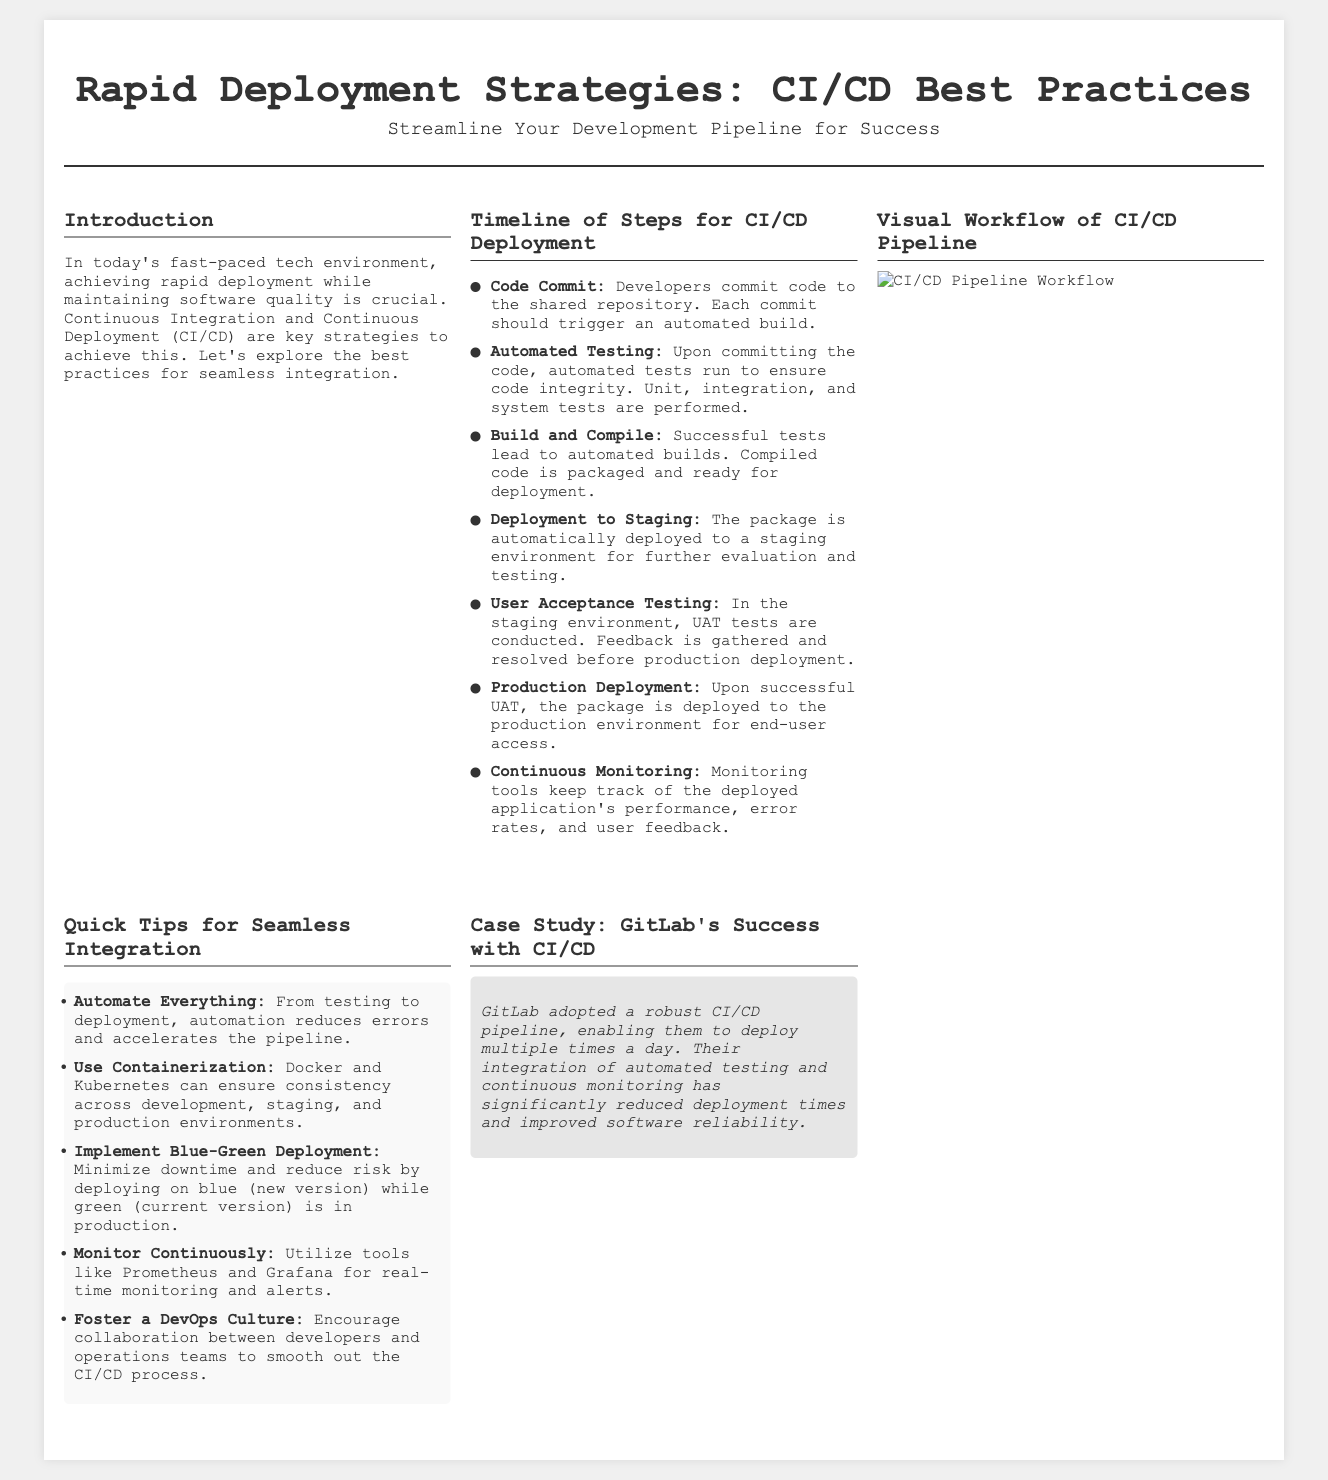What is the main title of the document? The title is prominently displayed at the top of the document, which is "Rapid Deployment Strategies: CI/CD Best Practices."
Answer: Rapid Deployment Strategies: CI/CD Best Practices How many steps are in the CI/CD timeline? The timeline section lists seven distinct steps for CI/CD deployment.
Answer: 7 What is the first step in the timeline? The first step is identified as "Code Commit," where developers commit code to the shared repository.
Answer: Code Commit What does UAT stand for? In the context of the document, UAT refers to "User Acceptance Testing," which is an important part of the CI/CD process.
Answer: User Acceptance Testing Which deployment strategy minimizes downtime? The document mentions "Blue-Green Deployment" as a strategy to minimize downtime during the deployment process.
Answer: Blue-Green Deployment Which company is highlighted in the case study? The case study section specifies GitLab as the company that successfully implemented a CI/CD pipeline.
Answer: GitLab What is one of the tools mentioned for real-time monitoring? The document references "Prometheus" as one of the tools that can be used for real-time monitoring.
Answer: Prometheus 